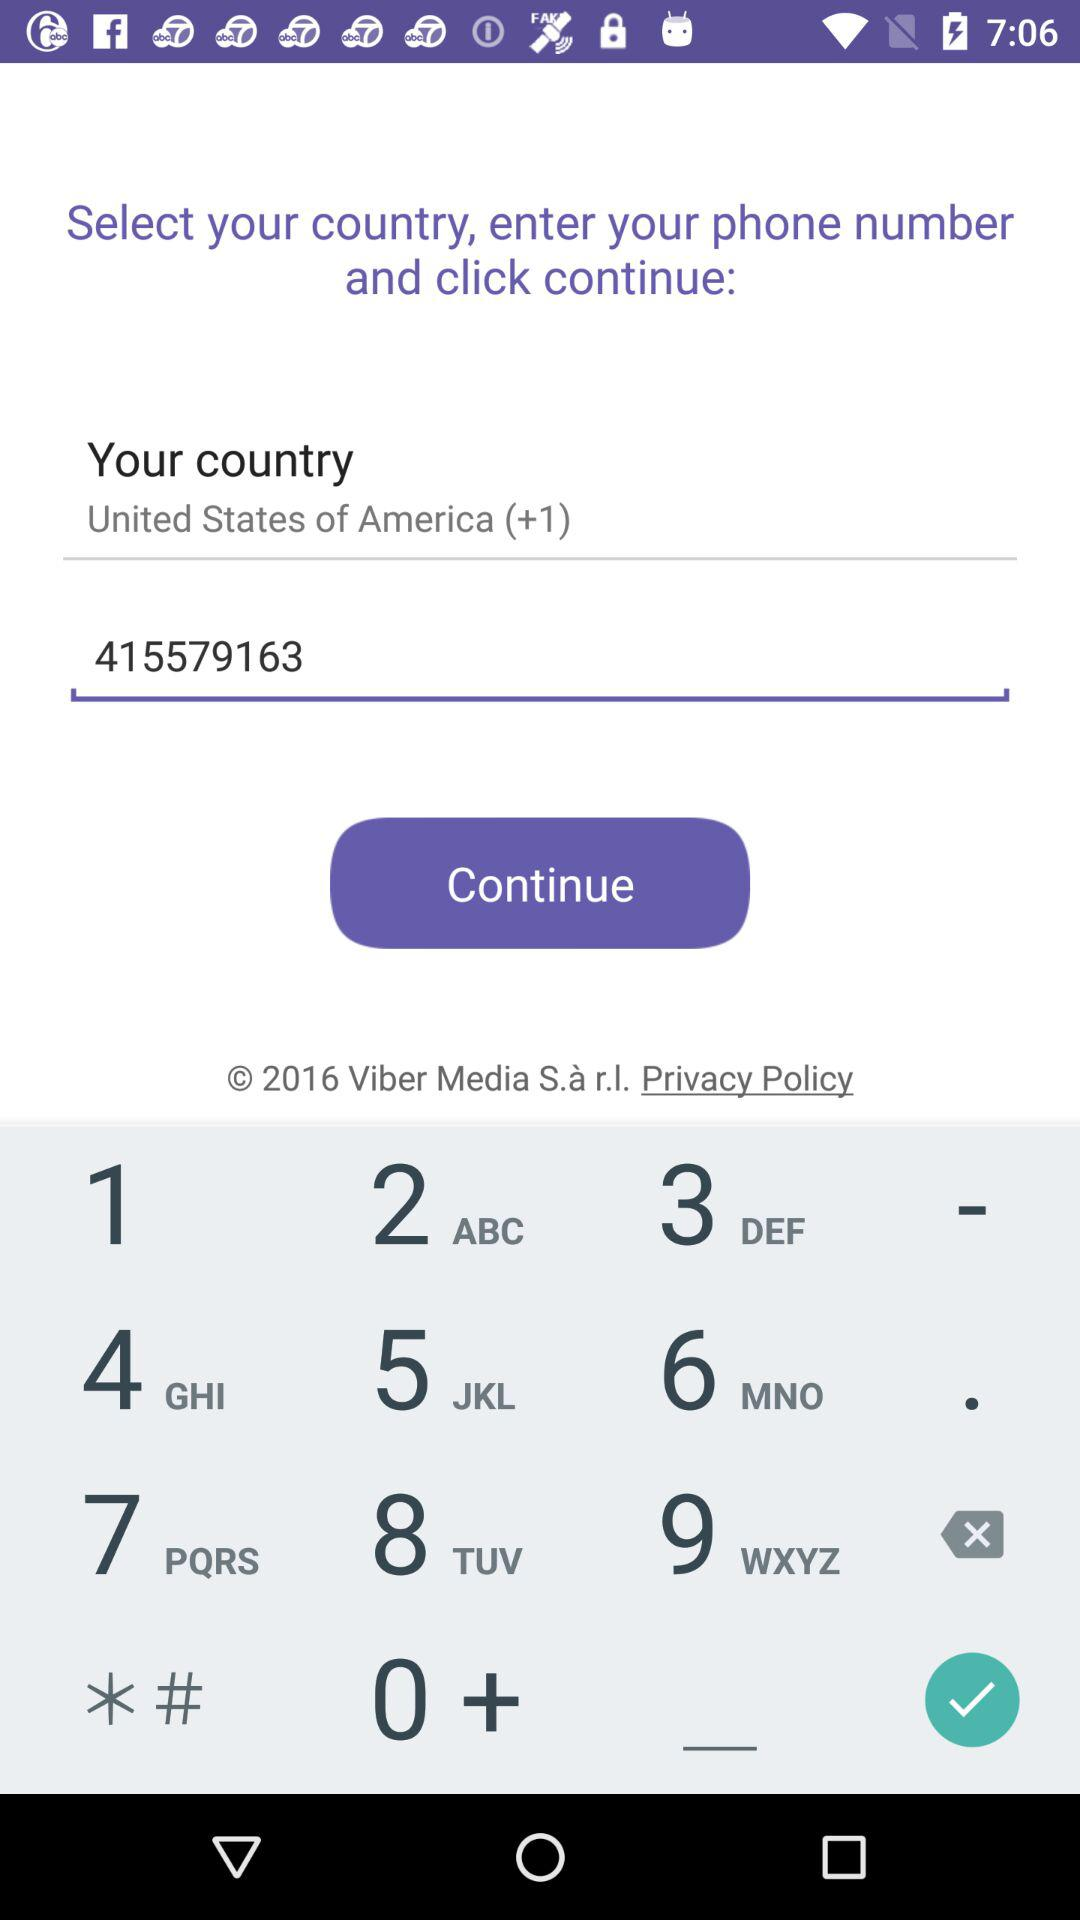What's the country's name? The country's name is the "United States of America". 